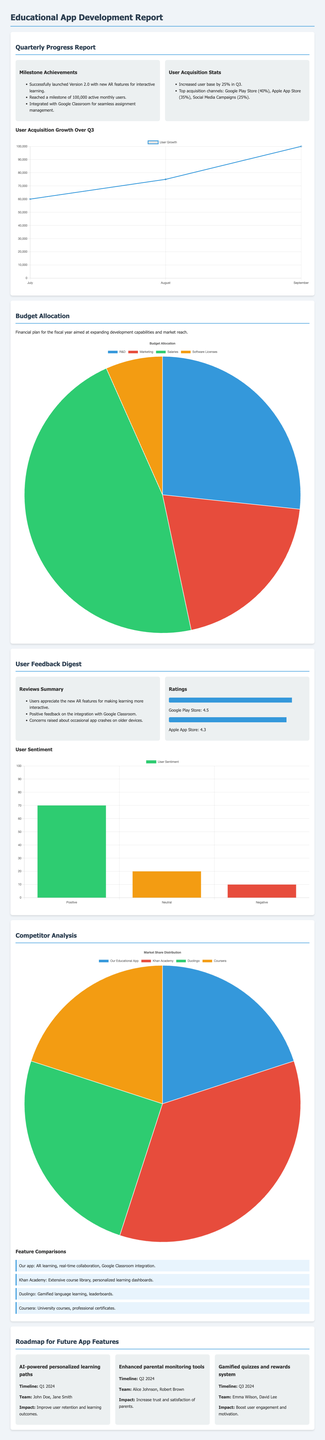What is the main milestone achievement in the quarterly progress report? The document highlights the successful launch of Version 2.0 with new AR features as a milestone achievement.
Answer: Successfully launched Version 2.0 with new AR features for interactive learning What percentage did the user base increase by in Q3? The user acquisition stats indicate that the user base increased by 25% during Q3.
Answer: 25% What is the highest rating on Google Play Store? The ratings section provides the Google Play Store rating, which is 4.5.
Answer: 4.5 How many active monthly users did the app reach? The document states that the app reached a milestone of 100,000 active monthly users.
Answer: 100,000 What is the budget percentage allocated to Salaries? The budget allocation breakdown shows that 43.75% is allocated to Salaries.
Answer: 43.75% What is one of the user concerns mentioned in the feedback digest? The user feedback digest mentions concerns about occasional app crashes on older devices.
Answer: Occasional app crashes on older devices Which team is responsible for the AI-powered personalized learning paths feature? The roadmap specifies that John Doe and Jane Smith are responsible for this feature.
Answer: John Doe, Jane Smith What is the market share percentage of Khan Academy? The competitor analysis report details that Khan Academy has a market share of 35%.
Answer: 35% Which feature is not offered by our educational app compared to competitors? The feature comparisons highlight that gamified language learning is unique to Duolingo.
Answer: Gamified language learning 